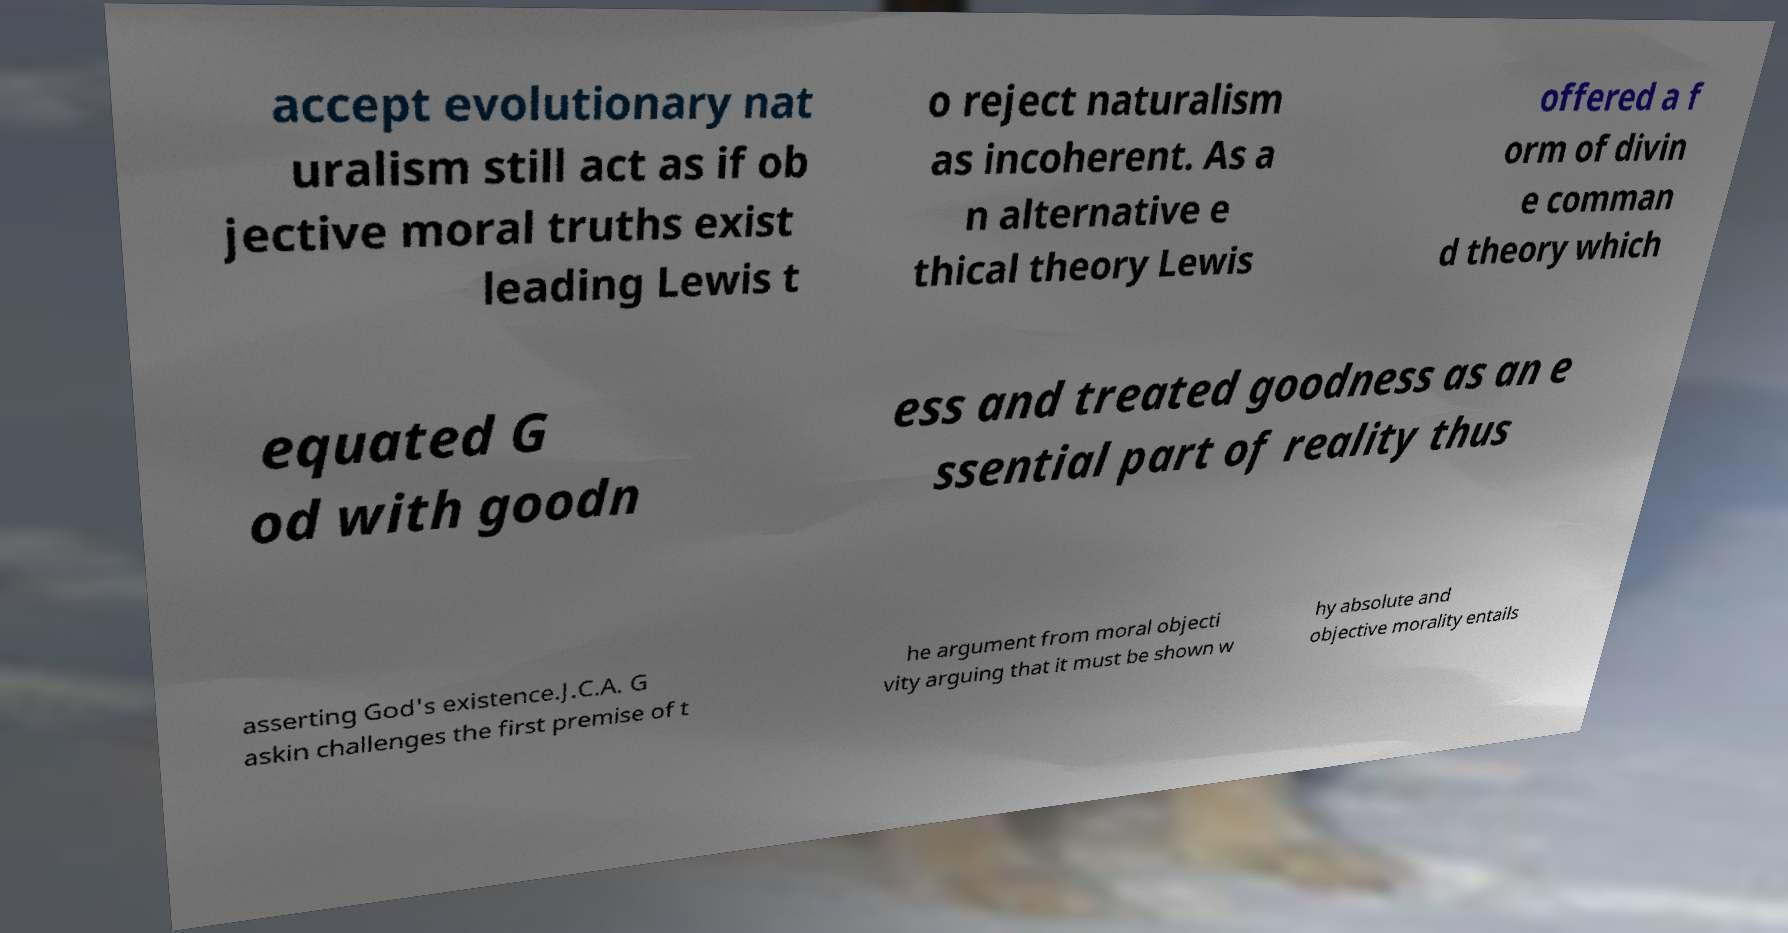There's text embedded in this image that I need extracted. Can you transcribe it verbatim? accept evolutionary nat uralism still act as if ob jective moral truths exist leading Lewis t o reject naturalism as incoherent. As a n alternative e thical theory Lewis offered a f orm of divin e comman d theory which equated G od with goodn ess and treated goodness as an e ssential part of reality thus asserting God's existence.J.C.A. G askin challenges the first premise of t he argument from moral objecti vity arguing that it must be shown w hy absolute and objective morality entails 